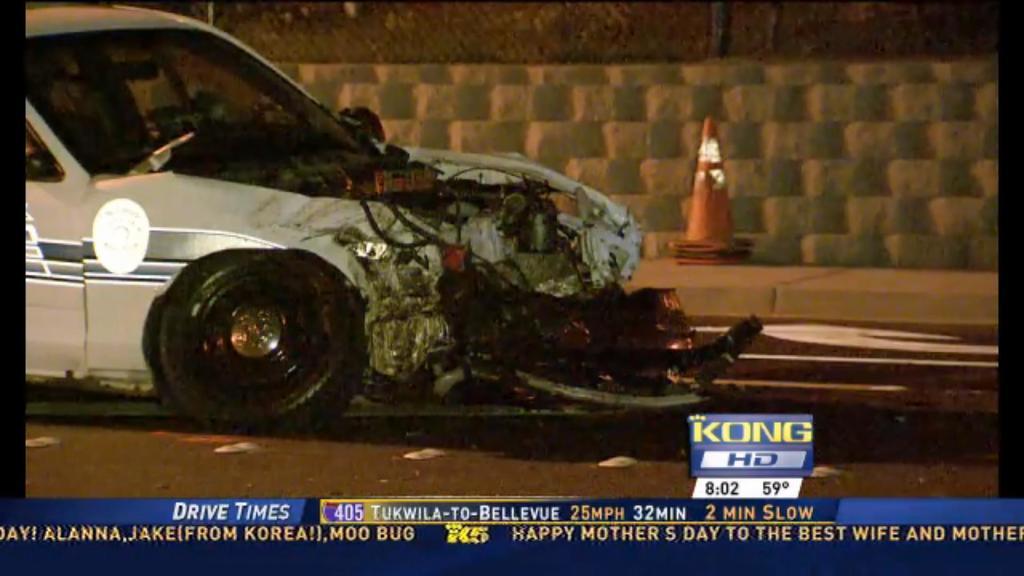What information is being given on the top blue banner?
Your answer should be very brief. Drive times. What is the temperature?
Offer a terse response. 59. 